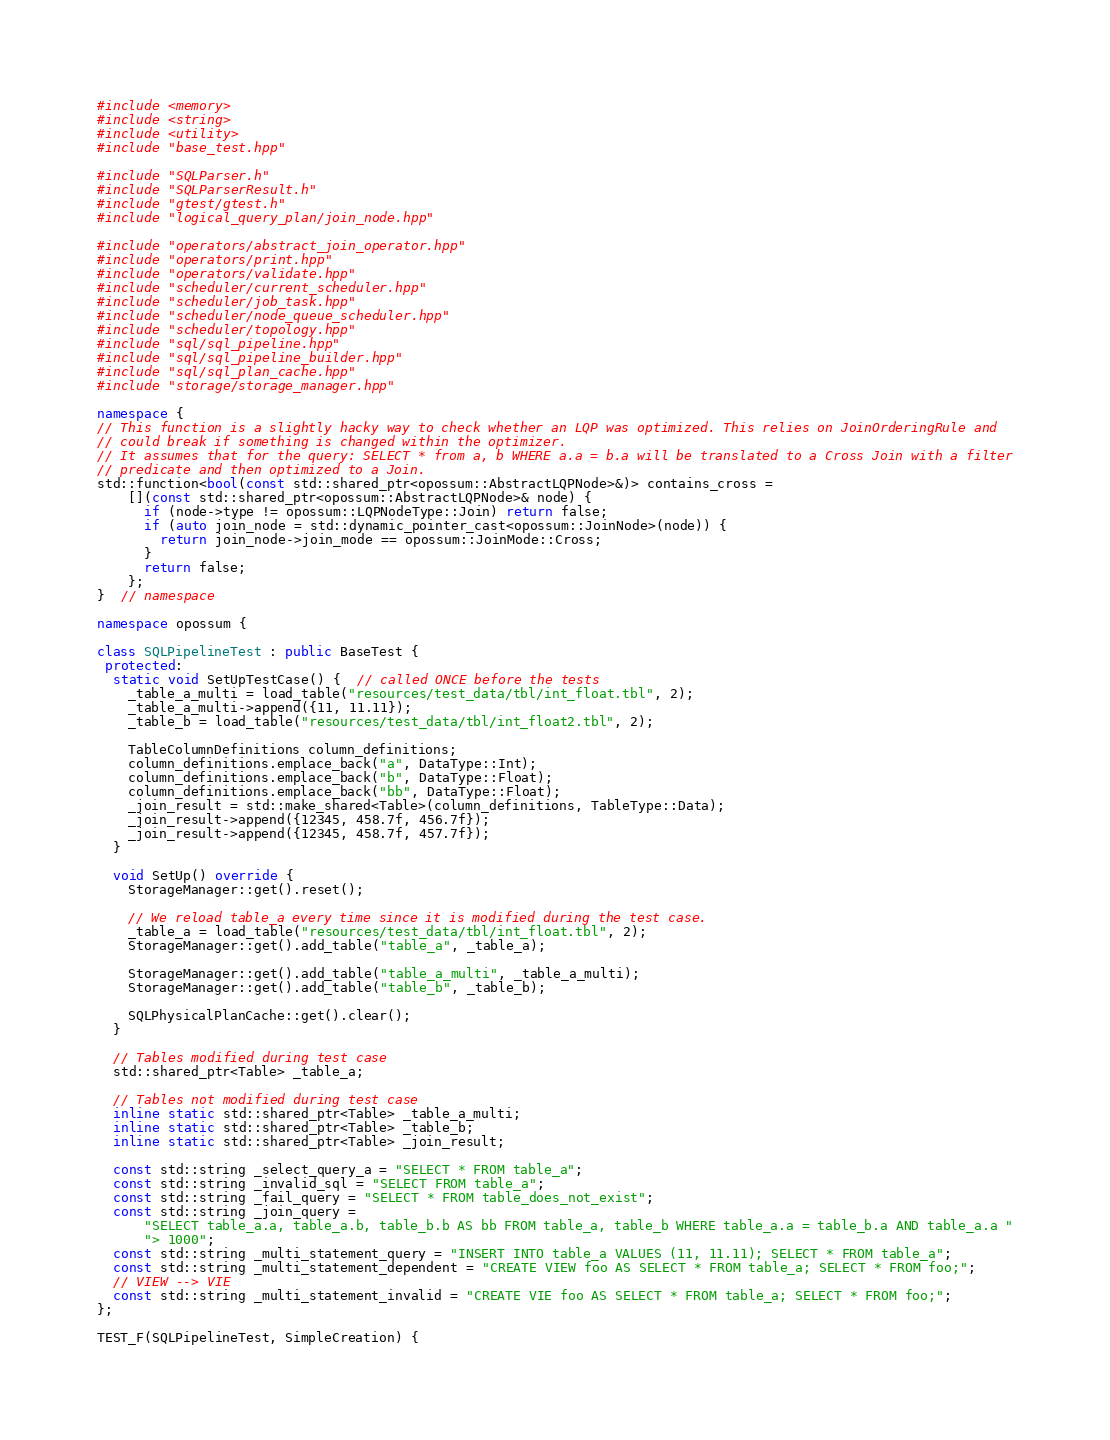Convert code to text. <code><loc_0><loc_0><loc_500><loc_500><_C++_>#include <memory>
#include <string>
#include <utility>
#include "base_test.hpp"

#include "SQLParser.h"
#include "SQLParserResult.h"
#include "gtest/gtest.h"
#include "logical_query_plan/join_node.hpp"

#include "operators/abstract_join_operator.hpp"
#include "operators/print.hpp"
#include "operators/validate.hpp"
#include "scheduler/current_scheduler.hpp"
#include "scheduler/job_task.hpp"
#include "scheduler/node_queue_scheduler.hpp"
#include "scheduler/topology.hpp"
#include "sql/sql_pipeline.hpp"
#include "sql/sql_pipeline_builder.hpp"
#include "sql/sql_plan_cache.hpp"
#include "storage/storage_manager.hpp"

namespace {
// This function is a slightly hacky way to check whether an LQP was optimized. This relies on JoinOrderingRule and
// could break if something is changed within the optimizer.
// It assumes that for the query: SELECT * from a, b WHERE a.a = b.a will be translated to a Cross Join with a filter
// predicate and then optimized to a Join.
std::function<bool(const std::shared_ptr<opossum::AbstractLQPNode>&)> contains_cross =
    [](const std::shared_ptr<opossum::AbstractLQPNode>& node) {
      if (node->type != opossum::LQPNodeType::Join) return false;
      if (auto join_node = std::dynamic_pointer_cast<opossum::JoinNode>(node)) {
        return join_node->join_mode == opossum::JoinMode::Cross;
      }
      return false;
    };
}  // namespace

namespace opossum {

class SQLPipelineTest : public BaseTest {
 protected:
  static void SetUpTestCase() {  // called ONCE before the tests
    _table_a_multi = load_table("resources/test_data/tbl/int_float.tbl", 2);
    _table_a_multi->append({11, 11.11});
    _table_b = load_table("resources/test_data/tbl/int_float2.tbl", 2);

    TableColumnDefinitions column_definitions;
    column_definitions.emplace_back("a", DataType::Int);
    column_definitions.emplace_back("b", DataType::Float);
    column_definitions.emplace_back("bb", DataType::Float);
    _join_result = std::make_shared<Table>(column_definitions, TableType::Data);
    _join_result->append({12345, 458.7f, 456.7f});
    _join_result->append({12345, 458.7f, 457.7f});
  }

  void SetUp() override {
    StorageManager::get().reset();

    // We reload table_a every time since it is modified during the test case.
    _table_a = load_table("resources/test_data/tbl/int_float.tbl", 2);
    StorageManager::get().add_table("table_a", _table_a);

    StorageManager::get().add_table("table_a_multi", _table_a_multi);
    StorageManager::get().add_table("table_b", _table_b);

    SQLPhysicalPlanCache::get().clear();
  }

  // Tables modified during test case
  std::shared_ptr<Table> _table_a;

  // Tables not modified during test case
  inline static std::shared_ptr<Table> _table_a_multi;
  inline static std::shared_ptr<Table> _table_b;
  inline static std::shared_ptr<Table> _join_result;

  const std::string _select_query_a = "SELECT * FROM table_a";
  const std::string _invalid_sql = "SELECT FROM table_a";
  const std::string _fail_query = "SELECT * FROM table_does_not_exist";
  const std::string _join_query =
      "SELECT table_a.a, table_a.b, table_b.b AS bb FROM table_a, table_b WHERE table_a.a = table_b.a AND table_a.a "
      "> 1000";
  const std::string _multi_statement_query = "INSERT INTO table_a VALUES (11, 11.11); SELECT * FROM table_a";
  const std::string _multi_statement_dependent = "CREATE VIEW foo AS SELECT * FROM table_a; SELECT * FROM foo;";
  // VIEW --> VIE
  const std::string _multi_statement_invalid = "CREATE VIE foo AS SELECT * FROM table_a; SELECT * FROM foo;";
};

TEST_F(SQLPipelineTest, SimpleCreation) {</code> 